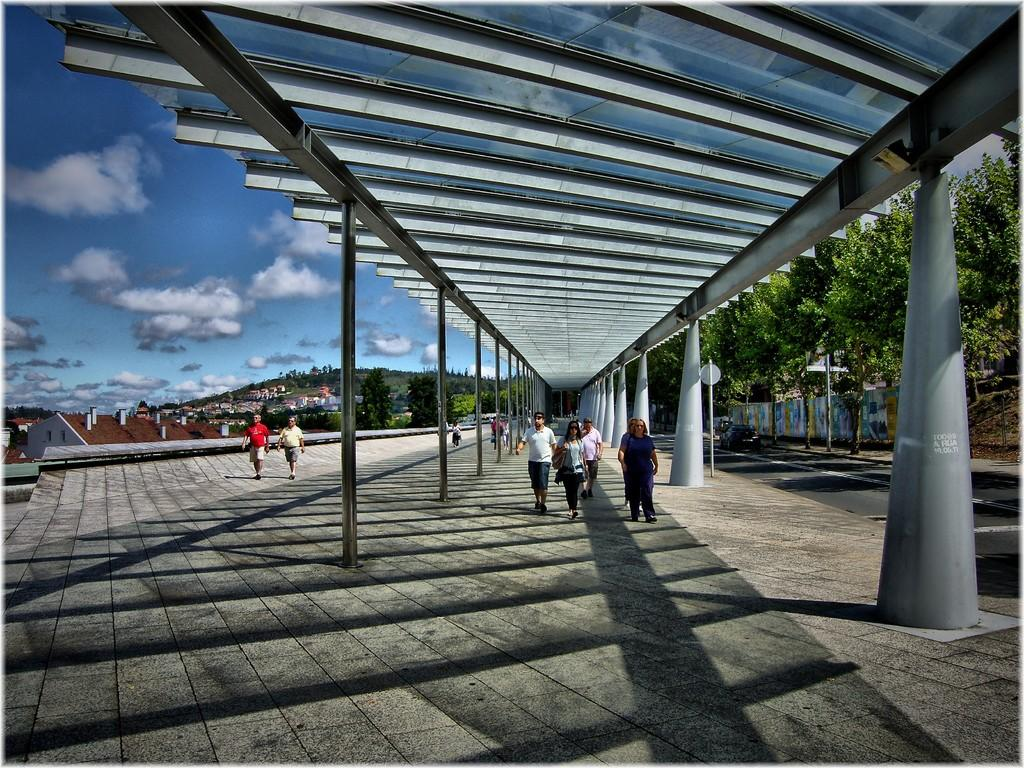What are the people in the image doing? The people in the image are walking in the center of the image. What type of vegetation is on the right side of the image? There are trees on the right side of the image. What can be seen in the background of the image? There is a hill and buildings in the background of the image. What is visible at the top of the image? The sky is visible at the top of the image. What type of beam can be seen supporting the sofa in the image? There is no sofa or beam present in the image. How many cans of soda are visible in the image? There are no cans of soda present in the image. 